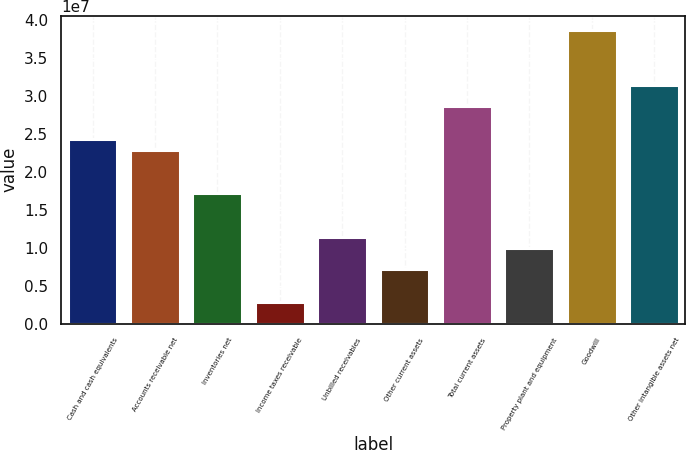Convert chart. <chart><loc_0><loc_0><loc_500><loc_500><bar_chart><fcel>Cash and cash equivalents<fcel>Accounts receivable net<fcel>Inventories net<fcel>Income taxes receivable<fcel>Unbilled receivables<fcel>Other current assets<fcel>Total current assets<fcel>Property plant and equipment<fcel>Goodwill<fcel>Other intangible assets net<nl><fcel>2.43372e+07<fcel>2.29056e+07<fcel>1.71795e+07<fcel>2.86412e+06<fcel>1.14533e+07<fcel>7.15873e+06<fcel>2.86318e+07<fcel>1.00218e+07<fcel>3.86525e+07<fcel>3.14949e+07<nl></chart> 